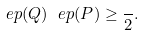Convert formula to latex. <formula><loc_0><loc_0><loc_500><loc_500>\ e p ( Q ) \ e p ( P ) \geq \frac { } { 2 } .</formula> 